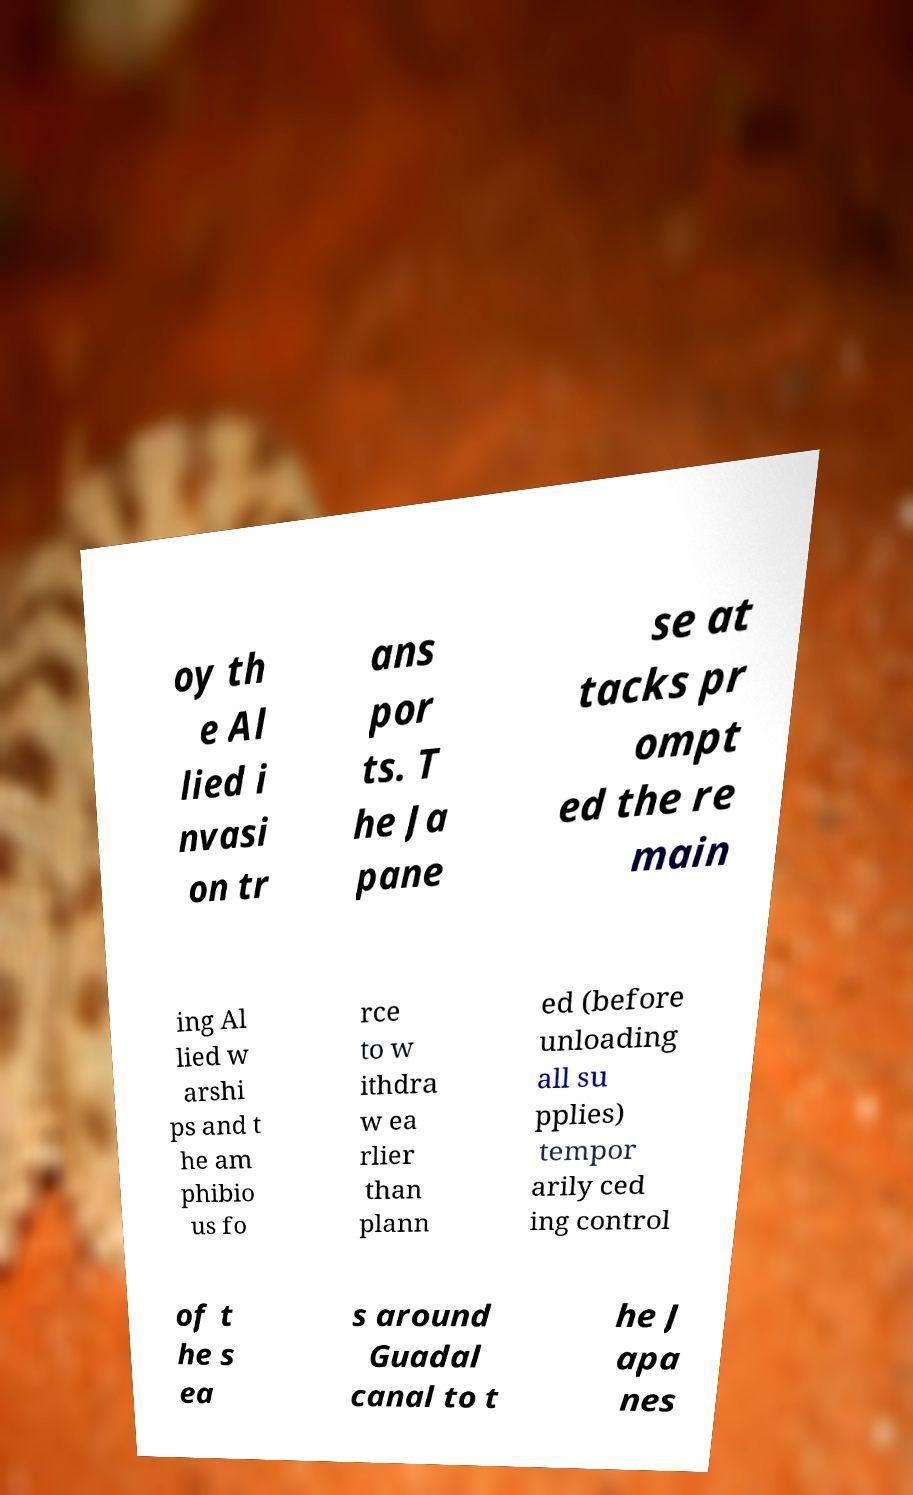I need the written content from this picture converted into text. Can you do that? oy th e Al lied i nvasi on tr ans por ts. T he Ja pane se at tacks pr ompt ed the re main ing Al lied w arshi ps and t he am phibio us fo rce to w ithdra w ea rlier than plann ed (before unloading all su pplies) tempor arily ced ing control of t he s ea s around Guadal canal to t he J apa nes 